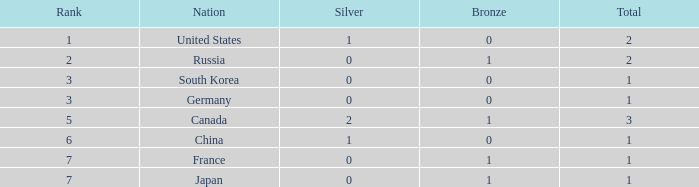Which Bronze has a Rank of 3, and a Silver larger than 0? None. 